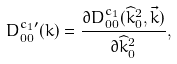<formula> <loc_0><loc_0><loc_500><loc_500>D ^ { c _ { 1 } \prime } _ { 0 0 } ( k ) = \frac { \partial D ^ { c _ { 1 } } _ { 0 0 } ( \widehat { k } _ { 0 } ^ { 2 } , \vec { k } ) } { \partial \widehat { k } _ { 0 } ^ { 2 } } ,</formula> 